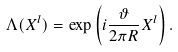<formula> <loc_0><loc_0><loc_500><loc_500>\Lambda ( X ^ { l } ) = \exp \left ( i \frac { \vartheta } { 2 \pi R } X ^ { l } \right ) .</formula> 